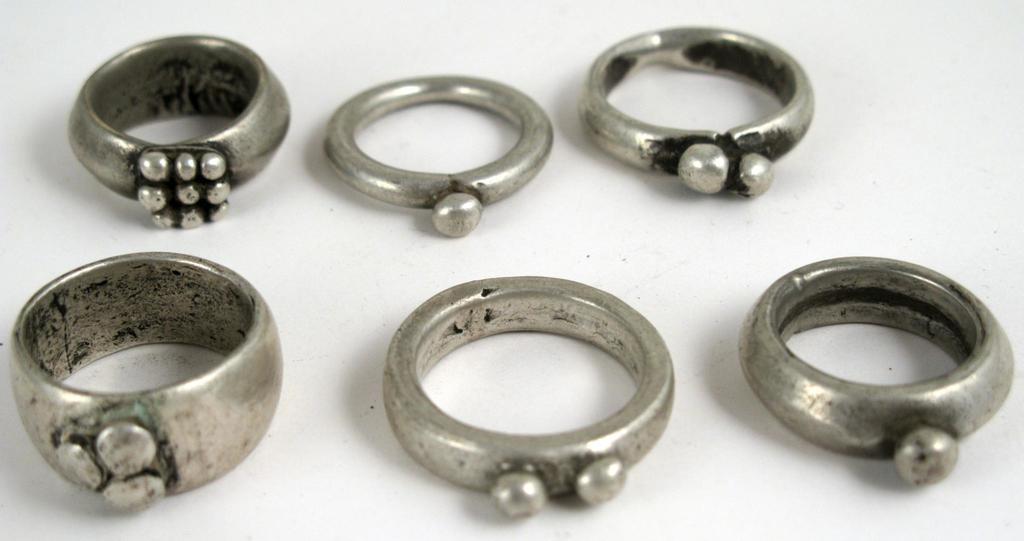Can you describe this image briefly? In this image there are silver rings, and there is a white background. 